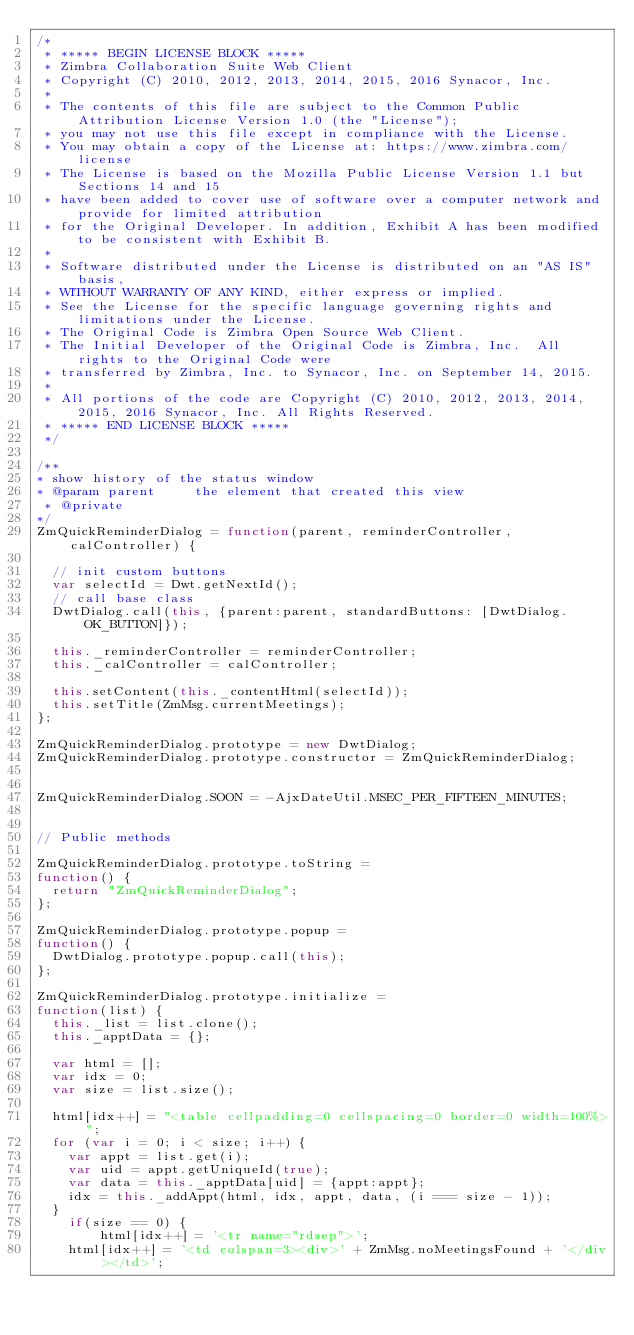Convert code to text. <code><loc_0><loc_0><loc_500><loc_500><_JavaScript_>/*
 * ***** BEGIN LICENSE BLOCK *****
 * Zimbra Collaboration Suite Web Client
 * Copyright (C) 2010, 2012, 2013, 2014, 2015, 2016 Synacor, Inc.
 *
 * The contents of this file are subject to the Common Public Attribution License Version 1.0 (the "License");
 * you may not use this file except in compliance with the License.
 * You may obtain a copy of the License at: https://www.zimbra.com/license
 * The License is based on the Mozilla Public License Version 1.1 but Sections 14 and 15
 * have been added to cover use of software over a computer network and provide for limited attribution
 * for the Original Developer. In addition, Exhibit A has been modified to be consistent with Exhibit B.
 *
 * Software distributed under the License is distributed on an "AS IS" basis,
 * WITHOUT WARRANTY OF ANY KIND, either express or implied.
 * See the License for the specific language governing rights and limitations under the License.
 * The Original Code is Zimbra Open Source Web Client.
 * The Initial Developer of the Original Code is Zimbra, Inc.  All rights to the Original Code were
 * transferred by Zimbra, Inc. to Synacor, Inc. on September 14, 2015.
 *
 * All portions of the code are Copyright (C) 2010, 2012, 2013, 2014, 2015, 2016 Synacor, Inc. All Rights Reserved.
 * ***** END LICENSE BLOCK *****
 */

/**
* show history of the status window
* @param parent			the element that created this view
 * @private
*/
ZmQuickReminderDialog = function(parent, reminderController, calController) {

	// init custom buttons
	var selectId = Dwt.getNextId();
	// call base class
	DwtDialog.call(this, {parent:parent, standardButtons: [DwtDialog.OK_BUTTON]});

	this._reminderController = reminderController;
	this._calController = calController;

	this.setContent(this._contentHtml(selectId));
	this.setTitle(ZmMsg.currentMeetings);
};

ZmQuickReminderDialog.prototype = new DwtDialog;
ZmQuickReminderDialog.prototype.constructor = ZmQuickReminderDialog;


ZmQuickReminderDialog.SOON = -AjxDateUtil.MSEC_PER_FIFTEEN_MINUTES;


// Public methods

ZmQuickReminderDialog.prototype.toString = 
function() {
	return "ZmQuickReminderDialog";
};

ZmQuickReminderDialog.prototype.popup =
function() {
	DwtDialog.prototype.popup.call(this);
};

ZmQuickReminderDialog.prototype.initialize =
function(list) {
	this._list = list.clone();
	this._apptData = {};

	var html = [];
	var idx = 0;
	var size = list.size();

	html[idx++] = "<table cellpadding=0 cellspacing=0 border=0 width=100%>";
	for (var i = 0; i < size; i++) {
		var appt = list.get(i);
		var uid = appt.getUniqueId(true);
		var data = this._apptData[uid] = {appt:appt};
		idx = this._addAppt(html, idx, appt, data, (i === size - 1));
	}
    if(size == 0) {
        html[idx++] = '<tr name="rdsep">';
		html[idx++] = '<td colspan=3><div>' + ZmMsg.noMeetingsFound + '</div></td>';</code> 